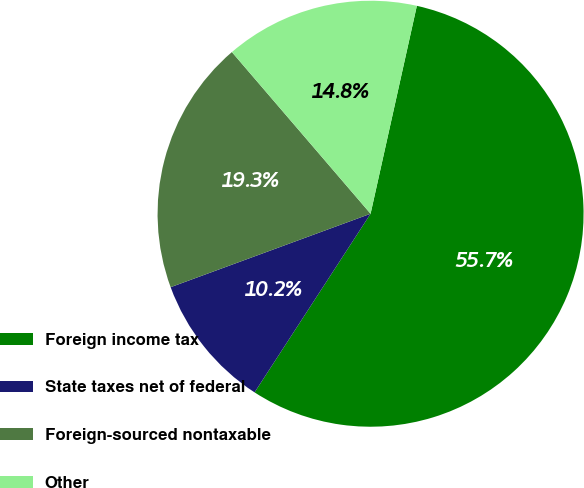Convert chart. <chart><loc_0><loc_0><loc_500><loc_500><pie_chart><fcel>Foreign income tax<fcel>State taxes net of federal<fcel>Foreign-sourced nontaxable<fcel>Other<nl><fcel>55.68%<fcel>10.23%<fcel>19.32%<fcel>14.77%<nl></chart> 